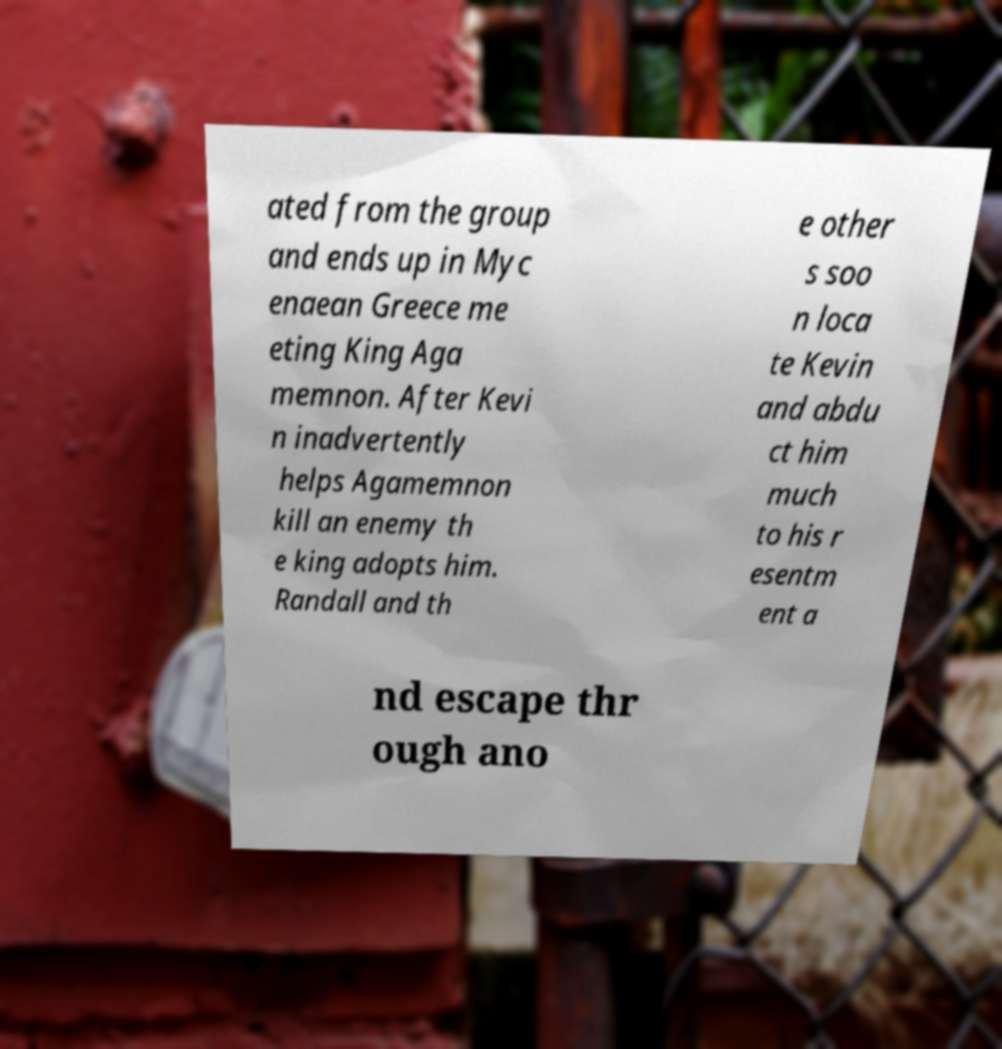Could you extract and type out the text from this image? ated from the group and ends up in Myc enaean Greece me eting King Aga memnon. After Kevi n inadvertently helps Agamemnon kill an enemy th e king adopts him. Randall and th e other s soo n loca te Kevin and abdu ct him much to his r esentm ent a nd escape thr ough ano 